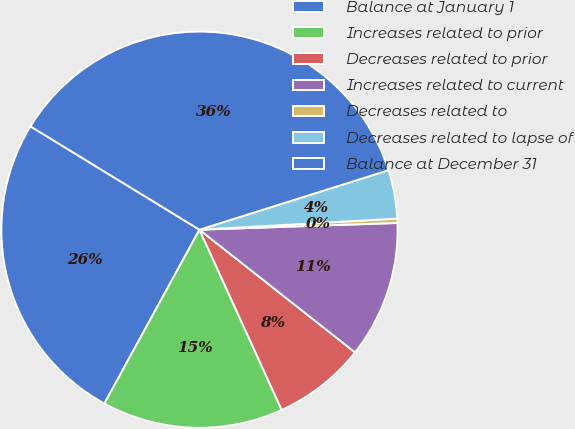<chart> <loc_0><loc_0><loc_500><loc_500><pie_chart><fcel>Balance at January 1<fcel>Increases related to prior<fcel>Decreases related to prior<fcel>Increases related to current<fcel>Decreases related to<fcel>Decreases related to lapse of<fcel>Balance at December 31<nl><fcel>25.77%<fcel>14.78%<fcel>7.56%<fcel>11.17%<fcel>0.35%<fcel>3.96%<fcel>36.41%<nl></chart> 